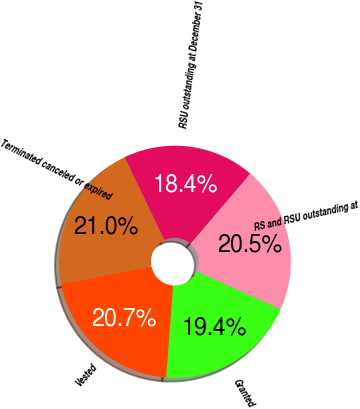Convert chart to OTSL. <chart><loc_0><loc_0><loc_500><loc_500><pie_chart><fcel>RS and RSU outstanding at<fcel>Granted<fcel>Vested<fcel>Terminated canceled or expired<fcel>RSU outstanding at December 31<nl><fcel>20.52%<fcel>19.44%<fcel>20.73%<fcel>20.95%<fcel>18.36%<nl></chart> 